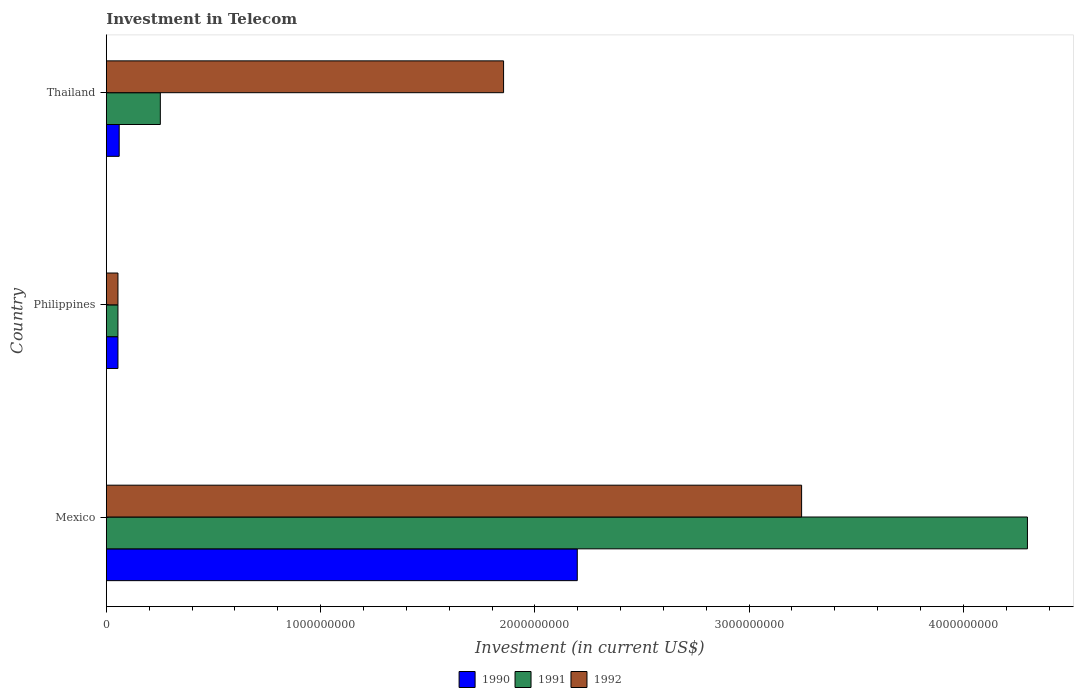How many different coloured bars are there?
Your answer should be very brief. 3. Are the number of bars on each tick of the Y-axis equal?
Provide a short and direct response. Yes. How many bars are there on the 3rd tick from the bottom?
Provide a short and direct response. 3. What is the amount invested in telecom in 1991 in Philippines?
Provide a short and direct response. 5.42e+07. Across all countries, what is the maximum amount invested in telecom in 1991?
Give a very brief answer. 4.30e+09. Across all countries, what is the minimum amount invested in telecom in 1992?
Give a very brief answer. 5.42e+07. In which country was the amount invested in telecom in 1990 minimum?
Offer a very short reply. Philippines. What is the total amount invested in telecom in 1990 in the graph?
Provide a succinct answer. 2.31e+09. What is the difference between the amount invested in telecom in 1990 in Philippines and that in Thailand?
Keep it short and to the point. -5.80e+06. What is the difference between the amount invested in telecom in 1992 in Thailand and the amount invested in telecom in 1991 in Philippines?
Keep it short and to the point. 1.80e+09. What is the average amount invested in telecom in 1991 per country?
Your answer should be very brief. 1.54e+09. What is the difference between the amount invested in telecom in 1990 and amount invested in telecom in 1992 in Mexico?
Your answer should be very brief. -1.05e+09. What is the ratio of the amount invested in telecom in 1990 in Philippines to that in Thailand?
Provide a succinct answer. 0.9. Is the amount invested in telecom in 1990 in Mexico less than that in Philippines?
Provide a short and direct response. No. Is the difference between the amount invested in telecom in 1990 in Mexico and Philippines greater than the difference between the amount invested in telecom in 1992 in Mexico and Philippines?
Give a very brief answer. No. What is the difference between the highest and the second highest amount invested in telecom in 1991?
Offer a very short reply. 4.05e+09. What is the difference between the highest and the lowest amount invested in telecom in 1992?
Make the answer very short. 3.19e+09. In how many countries, is the amount invested in telecom in 1992 greater than the average amount invested in telecom in 1992 taken over all countries?
Your response must be concise. 2. Is the sum of the amount invested in telecom in 1992 in Mexico and Thailand greater than the maximum amount invested in telecom in 1991 across all countries?
Your answer should be very brief. Yes. What does the 3rd bar from the bottom in Mexico represents?
Ensure brevity in your answer.  1992. Is it the case that in every country, the sum of the amount invested in telecom in 1991 and amount invested in telecom in 1992 is greater than the amount invested in telecom in 1990?
Give a very brief answer. Yes. Are all the bars in the graph horizontal?
Ensure brevity in your answer.  Yes. How many countries are there in the graph?
Offer a terse response. 3. What is the difference between two consecutive major ticks on the X-axis?
Your response must be concise. 1.00e+09. Where does the legend appear in the graph?
Offer a terse response. Bottom center. How many legend labels are there?
Your answer should be compact. 3. How are the legend labels stacked?
Offer a terse response. Horizontal. What is the title of the graph?
Give a very brief answer. Investment in Telecom. Does "2006" appear as one of the legend labels in the graph?
Offer a terse response. No. What is the label or title of the X-axis?
Give a very brief answer. Investment (in current US$). What is the label or title of the Y-axis?
Keep it short and to the point. Country. What is the Investment (in current US$) in 1990 in Mexico?
Ensure brevity in your answer.  2.20e+09. What is the Investment (in current US$) in 1991 in Mexico?
Provide a short and direct response. 4.30e+09. What is the Investment (in current US$) of 1992 in Mexico?
Ensure brevity in your answer.  3.24e+09. What is the Investment (in current US$) of 1990 in Philippines?
Ensure brevity in your answer.  5.42e+07. What is the Investment (in current US$) in 1991 in Philippines?
Ensure brevity in your answer.  5.42e+07. What is the Investment (in current US$) of 1992 in Philippines?
Offer a terse response. 5.42e+07. What is the Investment (in current US$) of 1990 in Thailand?
Ensure brevity in your answer.  6.00e+07. What is the Investment (in current US$) in 1991 in Thailand?
Your answer should be very brief. 2.52e+08. What is the Investment (in current US$) of 1992 in Thailand?
Your response must be concise. 1.85e+09. Across all countries, what is the maximum Investment (in current US$) of 1990?
Offer a terse response. 2.20e+09. Across all countries, what is the maximum Investment (in current US$) in 1991?
Ensure brevity in your answer.  4.30e+09. Across all countries, what is the maximum Investment (in current US$) of 1992?
Keep it short and to the point. 3.24e+09. Across all countries, what is the minimum Investment (in current US$) of 1990?
Your answer should be very brief. 5.42e+07. Across all countries, what is the minimum Investment (in current US$) in 1991?
Ensure brevity in your answer.  5.42e+07. Across all countries, what is the minimum Investment (in current US$) of 1992?
Make the answer very short. 5.42e+07. What is the total Investment (in current US$) in 1990 in the graph?
Your answer should be very brief. 2.31e+09. What is the total Investment (in current US$) of 1991 in the graph?
Your answer should be very brief. 4.61e+09. What is the total Investment (in current US$) of 1992 in the graph?
Give a very brief answer. 5.15e+09. What is the difference between the Investment (in current US$) in 1990 in Mexico and that in Philippines?
Keep it short and to the point. 2.14e+09. What is the difference between the Investment (in current US$) in 1991 in Mexico and that in Philippines?
Your answer should be very brief. 4.24e+09. What is the difference between the Investment (in current US$) of 1992 in Mexico and that in Philippines?
Keep it short and to the point. 3.19e+09. What is the difference between the Investment (in current US$) of 1990 in Mexico and that in Thailand?
Ensure brevity in your answer.  2.14e+09. What is the difference between the Investment (in current US$) of 1991 in Mexico and that in Thailand?
Your response must be concise. 4.05e+09. What is the difference between the Investment (in current US$) of 1992 in Mexico and that in Thailand?
Provide a succinct answer. 1.39e+09. What is the difference between the Investment (in current US$) of 1990 in Philippines and that in Thailand?
Provide a short and direct response. -5.80e+06. What is the difference between the Investment (in current US$) of 1991 in Philippines and that in Thailand?
Offer a very short reply. -1.98e+08. What is the difference between the Investment (in current US$) in 1992 in Philippines and that in Thailand?
Your response must be concise. -1.80e+09. What is the difference between the Investment (in current US$) of 1990 in Mexico and the Investment (in current US$) of 1991 in Philippines?
Ensure brevity in your answer.  2.14e+09. What is the difference between the Investment (in current US$) of 1990 in Mexico and the Investment (in current US$) of 1992 in Philippines?
Give a very brief answer. 2.14e+09. What is the difference between the Investment (in current US$) in 1991 in Mexico and the Investment (in current US$) in 1992 in Philippines?
Provide a succinct answer. 4.24e+09. What is the difference between the Investment (in current US$) of 1990 in Mexico and the Investment (in current US$) of 1991 in Thailand?
Offer a terse response. 1.95e+09. What is the difference between the Investment (in current US$) of 1990 in Mexico and the Investment (in current US$) of 1992 in Thailand?
Your answer should be very brief. 3.44e+08. What is the difference between the Investment (in current US$) in 1991 in Mexico and the Investment (in current US$) in 1992 in Thailand?
Make the answer very short. 2.44e+09. What is the difference between the Investment (in current US$) of 1990 in Philippines and the Investment (in current US$) of 1991 in Thailand?
Make the answer very short. -1.98e+08. What is the difference between the Investment (in current US$) in 1990 in Philippines and the Investment (in current US$) in 1992 in Thailand?
Offer a terse response. -1.80e+09. What is the difference between the Investment (in current US$) of 1991 in Philippines and the Investment (in current US$) of 1992 in Thailand?
Your response must be concise. -1.80e+09. What is the average Investment (in current US$) of 1990 per country?
Make the answer very short. 7.71e+08. What is the average Investment (in current US$) of 1991 per country?
Provide a short and direct response. 1.54e+09. What is the average Investment (in current US$) of 1992 per country?
Give a very brief answer. 1.72e+09. What is the difference between the Investment (in current US$) of 1990 and Investment (in current US$) of 1991 in Mexico?
Make the answer very short. -2.10e+09. What is the difference between the Investment (in current US$) of 1990 and Investment (in current US$) of 1992 in Mexico?
Provide a succinct answer. -1.05e+09. What is the difference between the Investment (in current US$) in 1991 and Investment (in current US$) in 1992 in Mexico?
Your answer should be compact. 1.05e+09. What is the difference between the Investment (in current US$) in 1990 and Investment (in current US$) in 1991 in Philippines?
Offer a very short reply. 0. What is the difference between the Investment (in current US$) in 1990 and Investment (in current US$) in 1991 in Thailand?
Offer a very short reply. -1.92e+08. What is the difference between the Investment (in current US$) of 1990 and Investment (in current US$) of 1992 in Thailand?
Make the answer very short. -1.79e+09. What is the difference between the Investment (in current US$) of 1991 and Investment (in current US$) of 1992 in Thailand?
Provide a succinct answer. -1.60e+09. What is the ratio of the Investment (in current US$) of 1990 in Mexico to that in Philippines?
Your answer should be very brief. 40.55. What is the ratio of the Investment (in current US$) in 1991 in Mexico to that in Philippines?
Give a very brief answer. 79.32. What is the ratio of the Investment (in current US$) in 1992 in Mexico to that in Philippines?
Your answer should be compact. 59.87. What is the ratio of the Investment (in current US$) in 1990 in Mexico to that in Thailand?
Your answer should be compact. 36.63. What is the ratio of the Investment (in current US$) in 1991 in Mexico to that in Thailand?
Keep it short and to the point. 17.06. What is the ratio of the Investment (in current US$) in 1992 in Mexico to that in Thailand?
Keep it short and to the point. 1.75. What is the ratio of the Investment (in current US$) in 1990 in Philippines to that in Thailand?
Offer a very short reply. 0.9. What is the ratio of the Investment (in current US$) in 1991 in Philippines to that in Thailand?
Make the answer very short. 0.22. What is the ratio of the Investment (in current US$) of 1992 in Philippines to that in Thailand?
Give a very brief answer. 0.03. What is the difference between the highest and the second highest Investment (in current US$) of 1990?
Offer a very short reply. 2.14e+09. What is the difference between the highest and the second highest Investment (in current US$) of 1991?
Keep it short and to the point. 4.05e+09. What is the difference between the highest and the second highest Investment (in current US$) in 1992?
Your answer should be compact. 1.39e+09. What is the difference between the highest and the lowest Investment (in current US$) in 1990?
Your answer should be compact. 2.14e+09. What is the difference between the highest and the lowest Investment (in current US$) of 1991?
Your response must be concise. 4.24e+09. What is the difference between the highest and the lowest Investment (in current US$) in 1992?
Offer a terse response. 3.19e+09. 